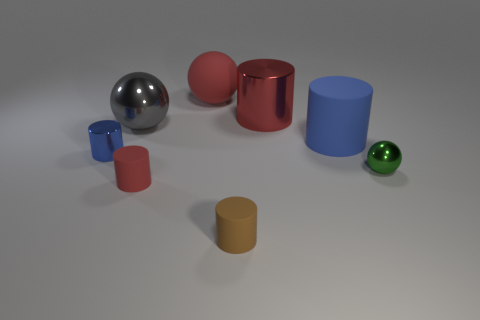Subtract all big spheres. How many spheres are left? 1 Add 2 large red rubber spheres. How many objects exist? 10 Subtract all balls. How many objects are left? 5 Subtract all red cylinders. How many cylinders are left? 3 Subtract 5 cylinders. How many cylinders are left? 0 Subtract all yellow cylinders. Subtract all red balls. How many cylinders are left? 5 Subtract all red cylinders. How many cyan spheres are left? 0 Subtract all tiny green spheres. Subtract all small brown matte cylinders. How many objects are left? 6 Add 4 red matte cylinders. How many red matte cylinders are left? 5 Add 7 tiny blue shiny things. How many tiny blue shiny things exist? 8 